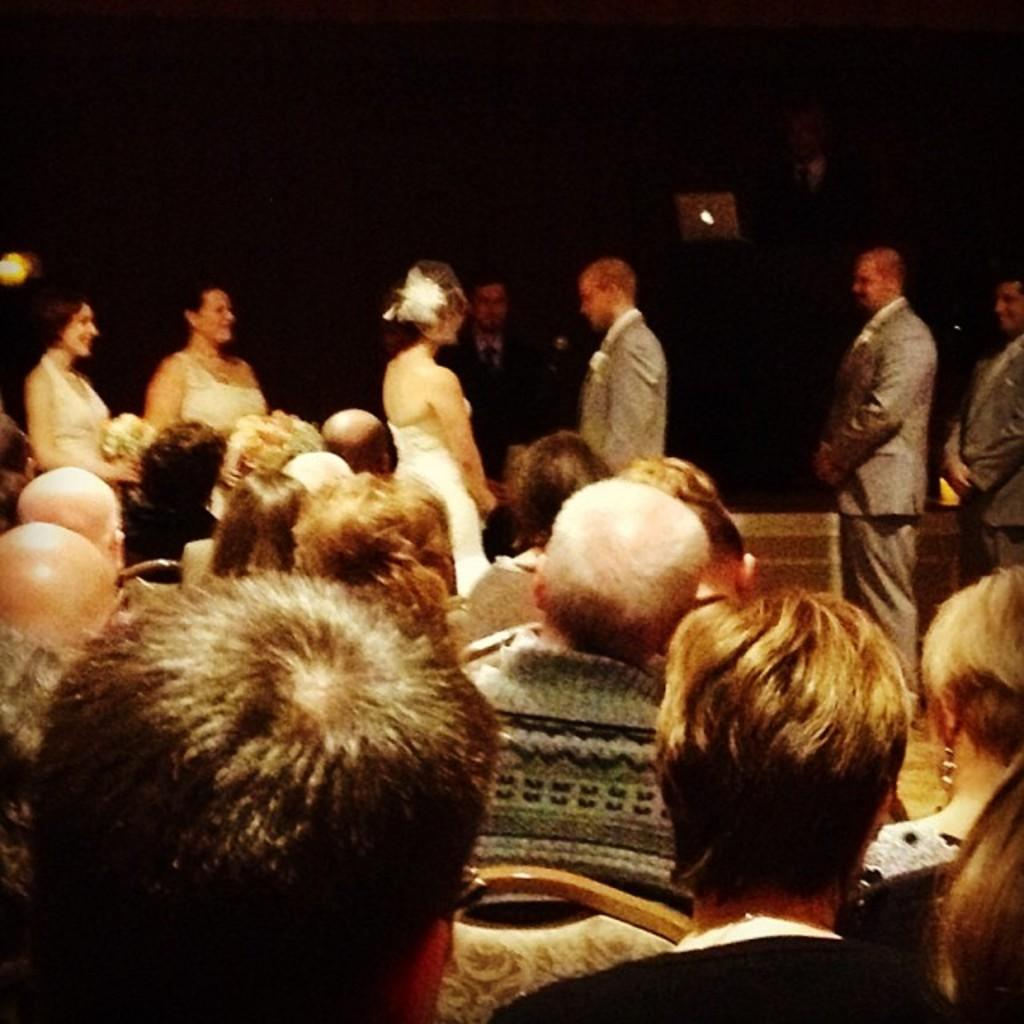What is the main subject of the image? The main subject of the image is a group of people. How are the people in the image positioned? Some people are sitting, while others are standing. What can be observed about the people's clothing? The people are wearing different color dresses. What is the color of the background in the image? The background of the image is black in color. What direction is the alarm sounding in the image? There is no alarm present in the image, so it cannot be determined in which direction it might be sounding. 